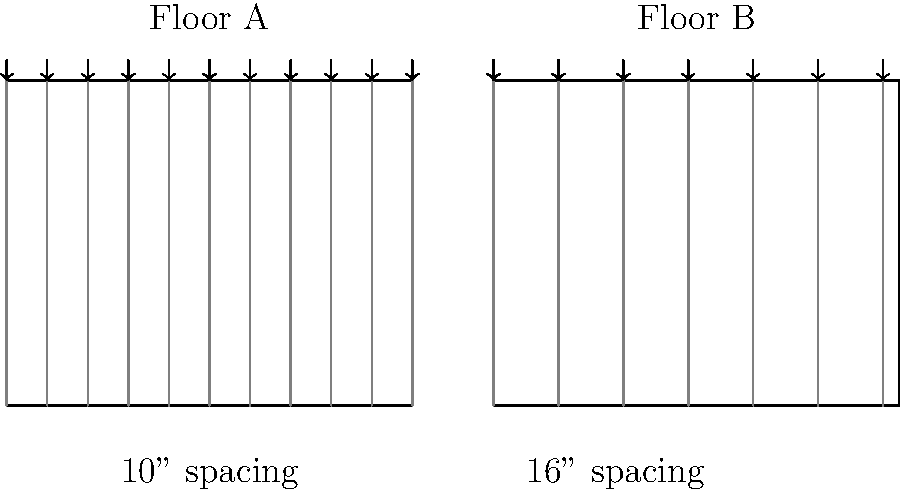As a new homeowner, you're considering renovating your living room floor. The contractor presents you with two options for floor joist spacing: Floor A with 10-inch spacing and Floor B with 16-inch spacing, as shown in the diagram. If both floors use the same type of joists, which floor (A or B) would have a higher load-bearing capacity, and why? To determine which floor has a higher load-bearing capacity, we need to consider the relationship between joist spacing and load distribution. Let's break it down step-by-step:

1. Joist function: Floor joists are horizontal structural members that support the weight of the floor, furniture, and occupants.

2. Load distribution: The closer the joists are spaced, the more evenly the load is distributed across the floor.

3. Comparing the floors:
   - Floor A: 10-inch spacing
   - Floor B: 16-inch spacing

4. Effect of spacing on load-bearing capacity:
   - Closer spacing (Floor A) means each joist supports a smaller area of the floor.
   - Wider spacing (Floor B) means each joist must support a larger area of the floor.

5. Load per joist:
   - In Floor A, the load is distributed among more joists.
   - In Floor B, fewer joists must bear the same total load.

6. Stress on individual joists:
   - Floor A: Lower stress on each joist due to better load distribution.
   - Floor B: Higher stress on each joist due to larger area supported by each.

7. Overall load-bearing capacity:
   - Floor A can support a higher total load because the weight is more evenly distributed among more joists.
   - Floor B has a lower overall load-bearing capacity because each joist is under more stress.

Therefore, Floor A with 10-inch joist spacing would have a higher load-bearing capacity compared to Floor B with 16-inch spacing.
Answer: Floor A (10-inch spacing) has higher load-bearing capacity. 